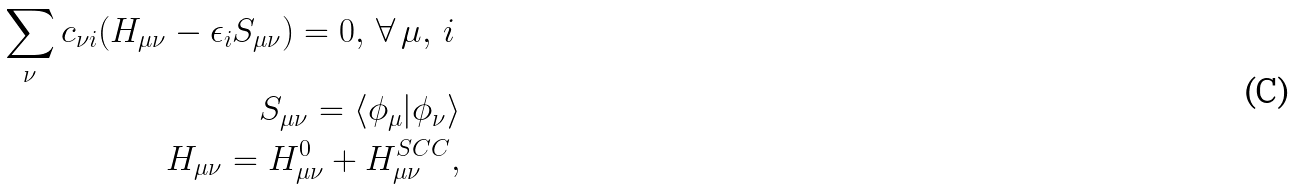Convert formula to latex. <formula><loc_0><loc_0><loc_500><loc_500>\sum _ { \nu } c _ { \nu i } ( H _ { \mu \nu } - \epsilon _ { i } S _ { \mu \nu } ) = 0 , \, \forall \, \mu , \, i \, \\ S _ { \mu \nu } = \langle \phi _ { \mu } | \phi _ { \nu } \rangle \\ H _ { \mu \nu } = H _ { \mu \nu } ^ { 0 } + H _ { \mu \nu } ^ { S C C } ,</formula> 